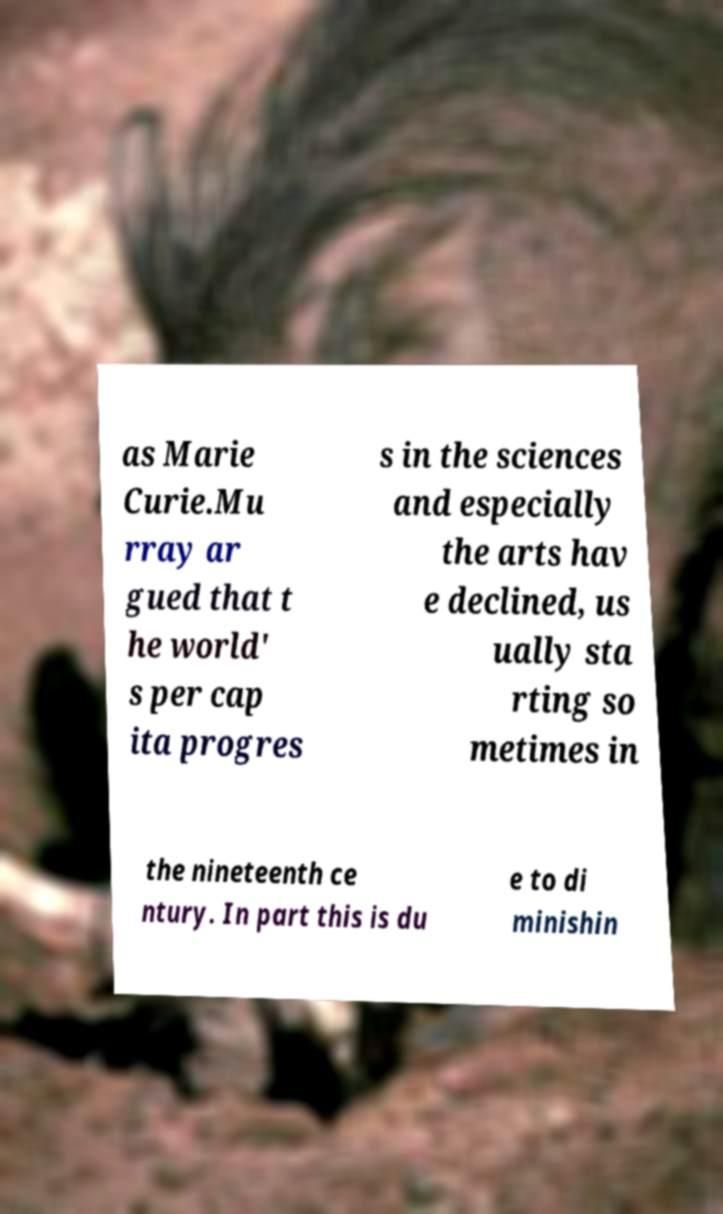There's text embedded in this image that I need extracted. Can you transcribe it verbatim? as Marie Curie.Mu rray ar gued that t he world' s per cap ita progres s in the sciences and especially the arts hav e declined, us ually sta rting so metimes in the nineteenth ce ntury. In part this is du e to di minishin 